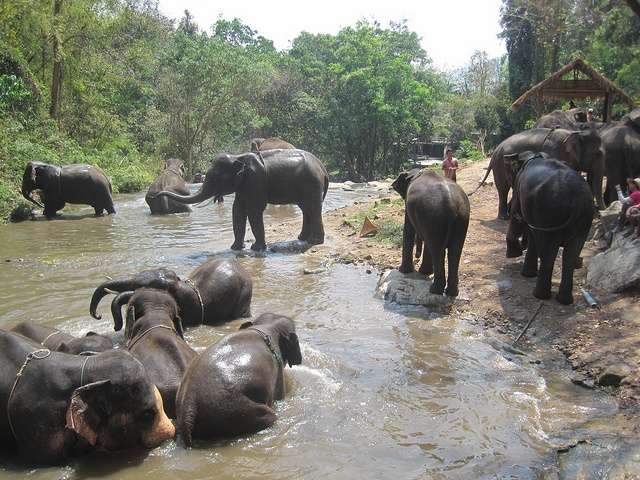Describe the objects in this image and their specific colors. I can see elephant in darkgreen, black, and gray tones, elephant in darkgreen, gray, black, and darkgray tones, elephant in darkgreen, black, and gray tones, elephant in darkgreen, black, gray, and darkgray tones, and elephant in darkgreen, black, gray, and darkgray tones in this image. 